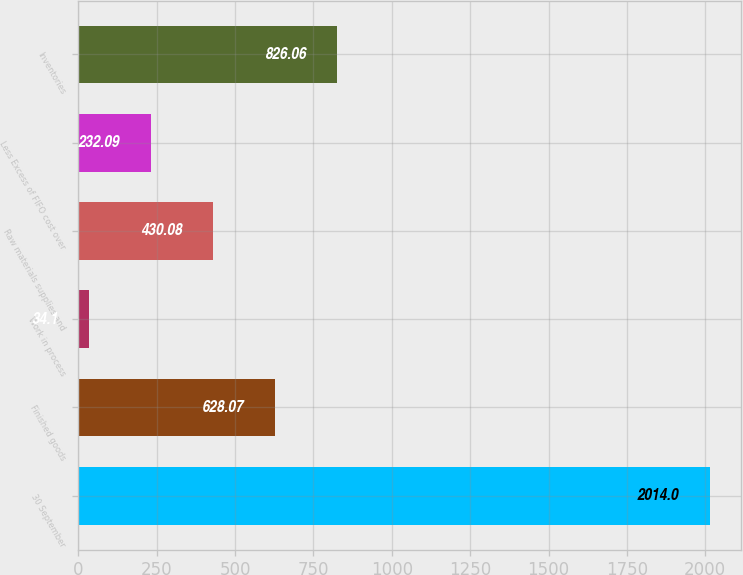Convert chart. <chart><loc_0><loc_0><loc_500><loc_500><bar_chart><fcel>30 September<fcel>Finished goods<fcel>Work in process<fcel>Raw materials supplies and<fcel>Less Excess of FIFO cost over<fcel>Inventories<nl><fcel>2014<fcel>628.07<fcel>34.1<fcel>430.08<fcel>232.09<fcel>826.06<nl></chart> 